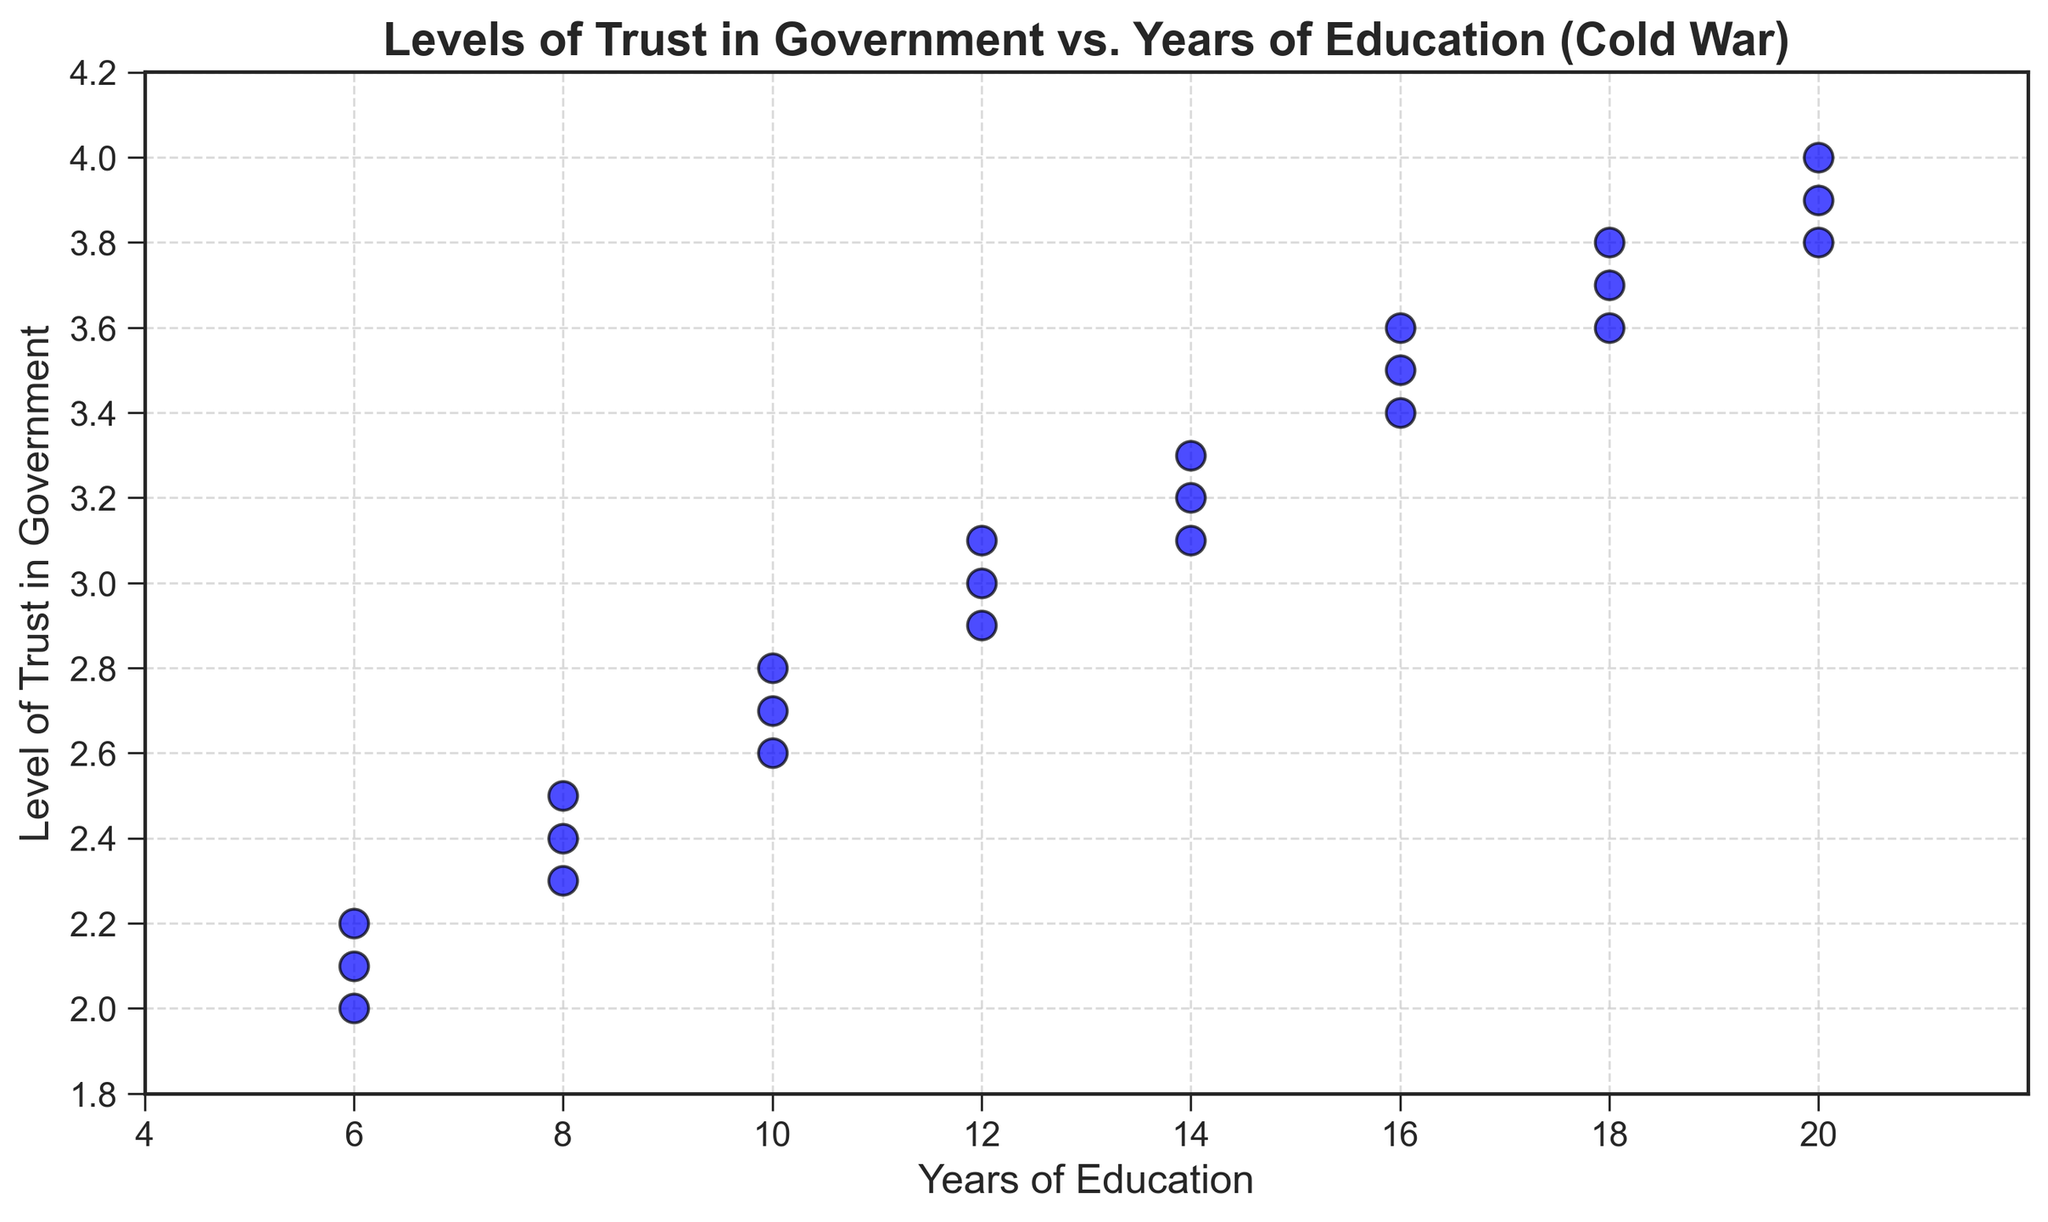What trend do you observe between the years of education and levels of trust in government? The scatter plot shows that as the years of education increase, the levels of trust in government also generally increase. This upward trend is consistent across the education levels from 6 to 20 years.
Answer: Increasing trend Is there any clear outlier in the data? From the scatter plot, all data points appear to follow the general upward trend with no significant deviation. Therefore, there is no clear outlier in the data.
Answer: No What is the highest level of trust in government observed and at what year of education? The highest level of trust in government observed in the scatter plot is 4.0, which is associated with 20 years of education.
Answer: 4.0 at 20 years What is the average level of trust in government for citizens with 12 years of education? The data points for 12 years of education have levels of trust in government as 3.0, 2.9, and 3.1. The average can be calculated as (3.0 + 2.9 + 3.1) / 3 = 3.0.
Answer: 3.0 Which education level shows the least variability in levels of trust in government? By observing the scatter plot, the levels of trust for 18 years of education (3.7, 3.6, 3.8) show the least variability as they are closer to each other compared to other education levels.
Answer: 18 years How does the level of trust in government change between 14 and 16 years of education? For 14 years of education, the levels of trust in government are 3.2, 3.1, and 3.3. For 16 years of education, the values are 3.5, 3.4, and 3.6. There is an increase in trust from the 14-year marks to the 16-year marks, indicating a general rise.
Answer: Increase Do any two education levels have overlapping trust ranges? Yes, the trust ranges overlap for several education levels. For instance, 14 years (3.2, 3.1, 3.3) and 16 years (3.5, 3.4, 3.6) show some overlap around the value of 3.
Answer: Yes What's the median level of trust observed for all data points in the plot, and which education levels correspond to this value? To find the median, list all levels of trust: 2.0, 2.1, 2.2, 2.3, 2.4, 2.5, 2.6, 2.7, 2.8, 2.9, 3.0, 3.0, 3.1, 3.1, 3.2, 3.3, 3.4, 3.5, 3.6, 3.6, 3.7, 3.8, 3.8, 3.9, 4.0. The median is the middle number, which is 3.2. Education levels corresponding to 3.2 are 14 years.
Answer: 3.2 from 14 years What is the observed range of levels of trust for 6 years of education? The levels of trust for 6 years of education are 2.1, 2.0, and 2.2. The range is calculated as the difference between the maximum and minimum values: 2.2 - 2.0 = 0.2.
Answer: 0.2 